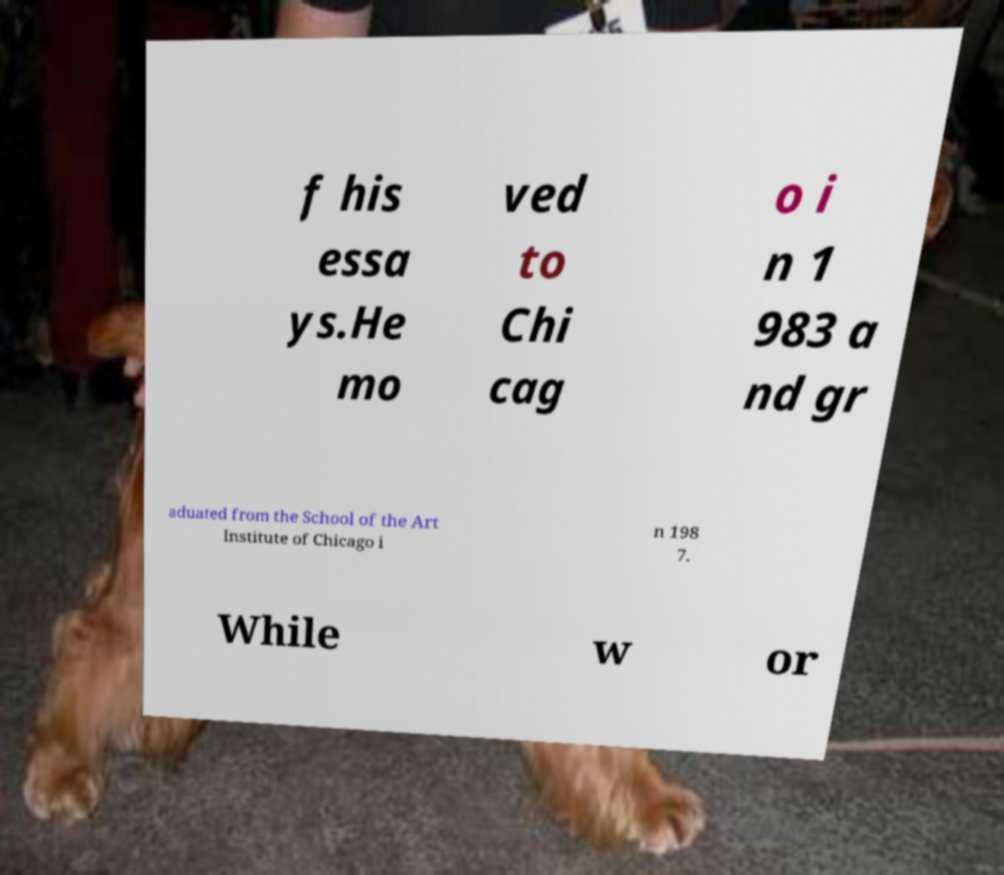Could you extract and type out the text from this image? f his essa ys.He mo ved to Chi cag o i n 1 983 a nd gr aduated from the School of the Art Institute of Chicago i n 198 7. While w or 